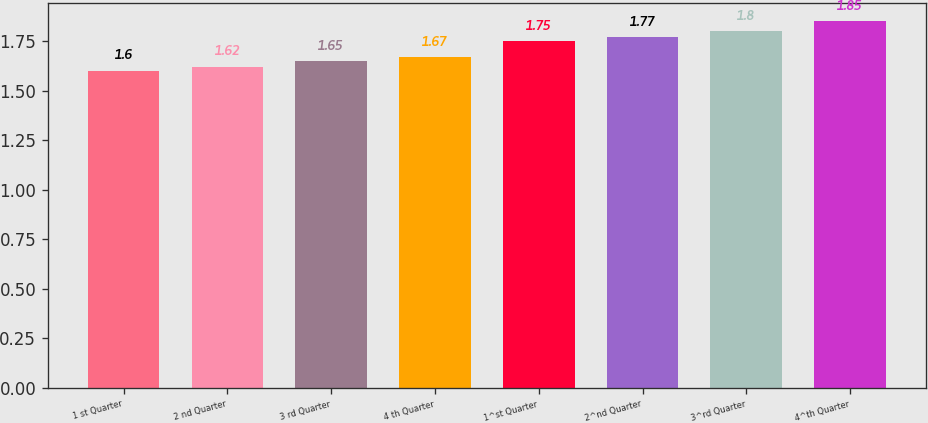Convert chart to OTSL. <chart><loc_0><loc_0><loc_500><loc_500><bar_chart><fcel>1 st Quarter<fcel>2 nd Quarter<fcel>3 rd Quarter<fcel>4 th Quarter<fcel>1^st Quarter<fcel>2^nd Quarter<fcel>3^rd Quarter<fcel>4^th Quarter<nl><fcel>1.6<fcel>1.62<fcel>1.65<fcel>1.67<fcel>1.75<fcel>1.77<fcel>1.8<fcel>1.85<nl></chart> 